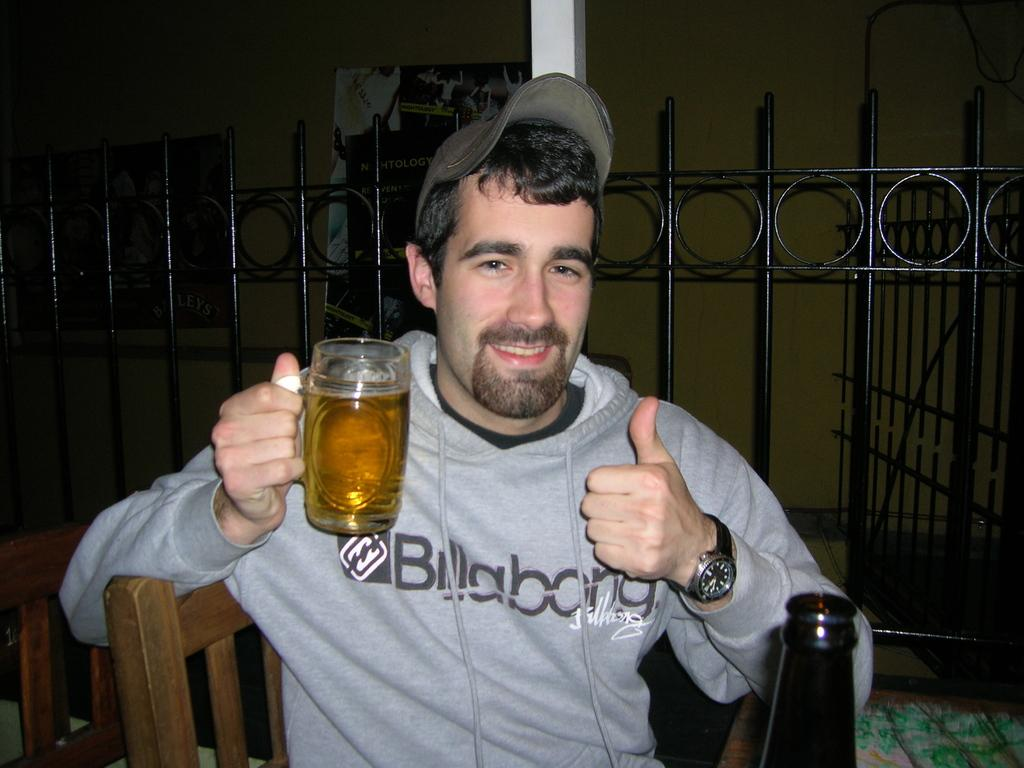Who is present in the image? There is a man in the image. What is the man wearing on his upper body? The man is wearing a jacket. What is the man wearing on his head? The man is wearing a cap. What accessory is the man wearing on his wrist? The man is wearing a watch. What is the man holding in his hand? The man is holding a glass with a drink in it. What is the man sitting on in the image? The man is sitting on a chair. What can be seen in the background of the image? There is a fence in the background of the image. What type of receipt is the man holding in his hand? The man is not holding a receipt in his hand; he is holding a glass with a drink in it. What ornament is hanging from the fence in the background? There is no ornament visible on the fence in the background of the image. 